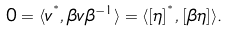Convert formula to latex. <formula><loc_0><loc_0><loc_500><loc_500>0 = \langle v ^ { ^ { * } } , { \beta } v { \beta } ^ { - 1 } \rangle = \langle [ \eta ] ^ { ^ { * } } , [ { \beta } \eta ] \rangle .</formula> 